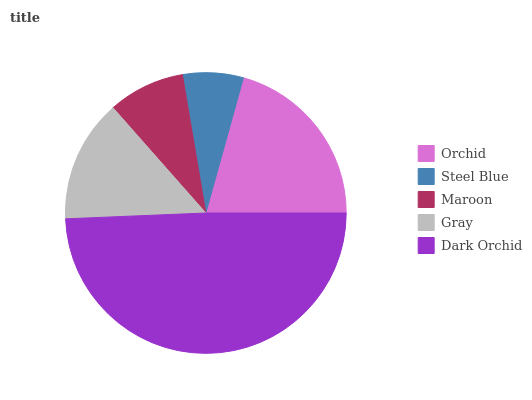Is Steel Blue the minimum?
Answer yes or no. Yes. Is Dark Orchid the maximum?
Answer yes or no. Yes. Is Maroon the minimum?
Answer yes or no. No. Is Maroon the maximum?
Answer yes or no. No. Is Maroon greater than Steel Blue?
Answer yes or no. Yes. Is Steel Blue less than Maroon?
Answer yes or no. Yes. Is Steel Blue greater than Maroon?
Answer yes or no. No. Is Maroon less than Steel Blue?
Answer yes or no. No. Is Gray the high median?
Answer yes or no. Yes. Is Gray the low median?
Answer yes or no. Yes. Is Maroon the high median?
Answer yes or no. No. Is Steel Blue the low median?
Answer yes or no. No. 